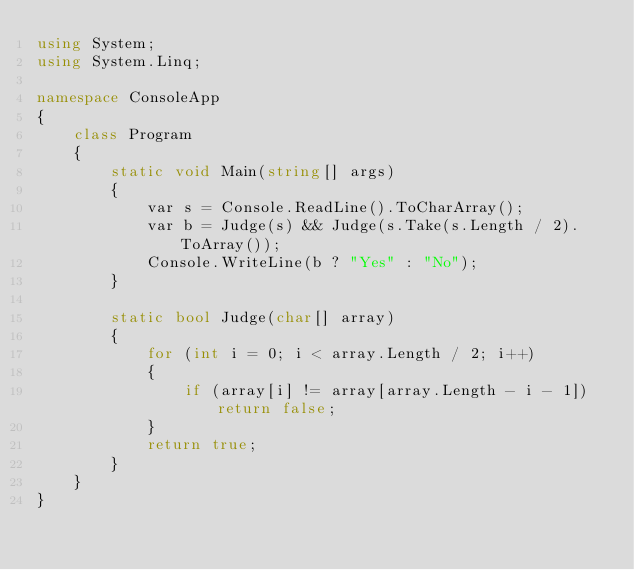<code> <loc_0><loc_0><loc_500><loc_500><_C#_>using System;
using System.Linq;

namespace ConsoleApp
{
    class Program
    {
        static void Main(string[] args)
        {
            var s = Console.ReadLine().ToCharArray();
            var b = Judge(s) && Judge(s.Take(s.Length / 2).ToArray());
            Console.WriteLine(b ? "Yes" : "No");
        }

        static bool Judge(char[] array)
        {
            for (int i = 0; i < array.Length / 2; i++)
            {
                if (array[i] != array[array.Length - i - 1]) return false;
            }
            return true;
        }
    }
}
</code> 